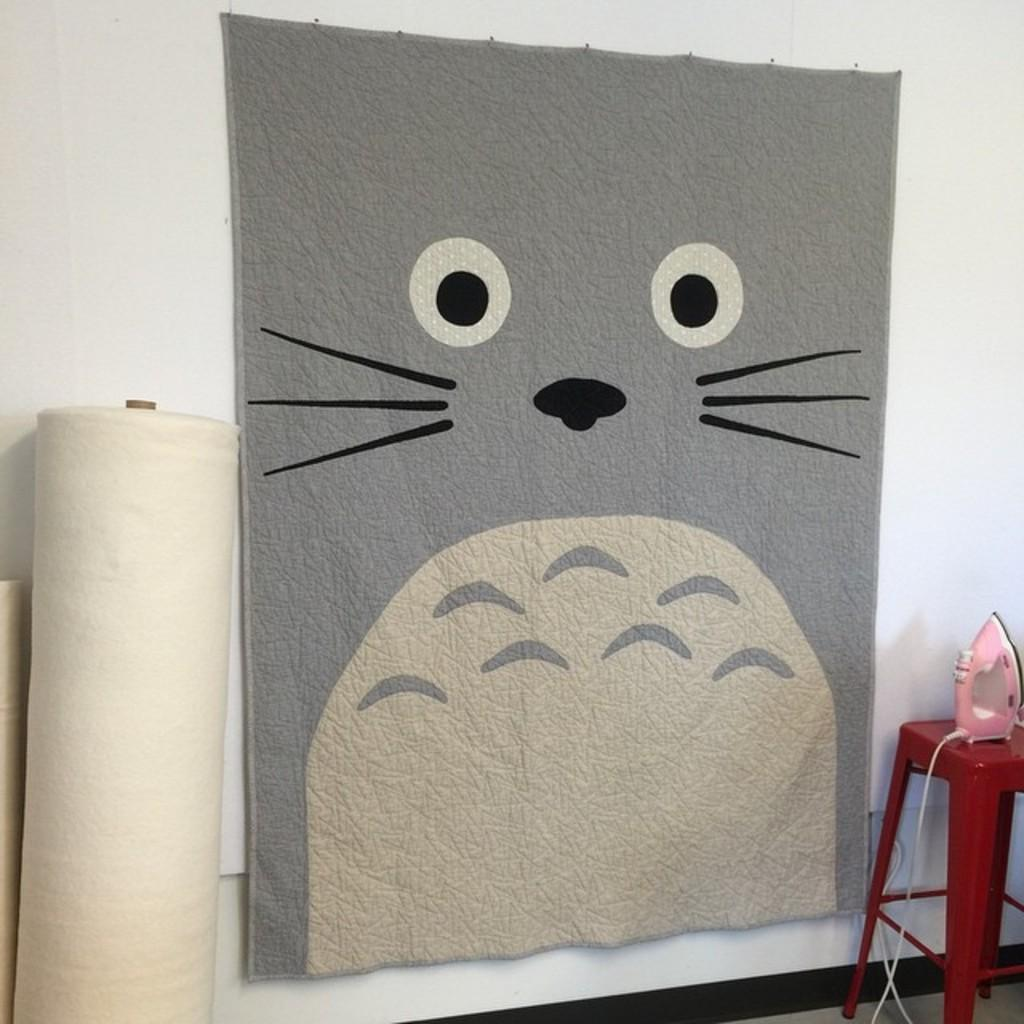What object is placed on the table in the image? There is an iron box on the table. What can be seen on the left side of the image? There are white objects visible on the left side. What is the cloth placed on in the image? The cloth is placed on a white surface. What type of fang can be seen in the image? There is no fang present in the image. Can you tell me how many aunts are visible in the image? There are no people, including aunts, present in the image. 